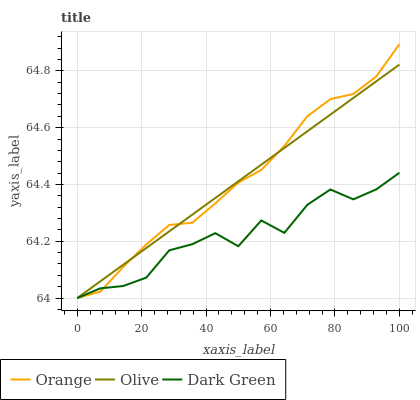Does Dark Green have the minimum area under the curve?
Answer yes or no. Yes. Does Orange have the maximum area under the curve?
Answer yes or no. Yes. Does Olive have the minimum area under the curve?
Answer yes or no. No. Does Olive have the maximum area under the curve?
Answer yes or no. No. Is Olive the smoothest?
Answer yes or no. Yes. Is Dark Green the roughest?
Answer yes or no. Yes. Is Dark Green the smoothest?
Answer yes or no. No. Is Olive the roughest?
Answer yes or no. No. Does Orange have the lowest value?
Answer yes or no. Yes. Does Orange have the highest value?
Answer yes or no. Yes. Does Olive have the highest value?
Answer yes or no. No. Does Orange intersect Olive?
Answer yes or no. Yes. Is Orange less than Olive?
Answer yes or no. No. Is Orange greater than Olive?
Answer yes or no. No. 